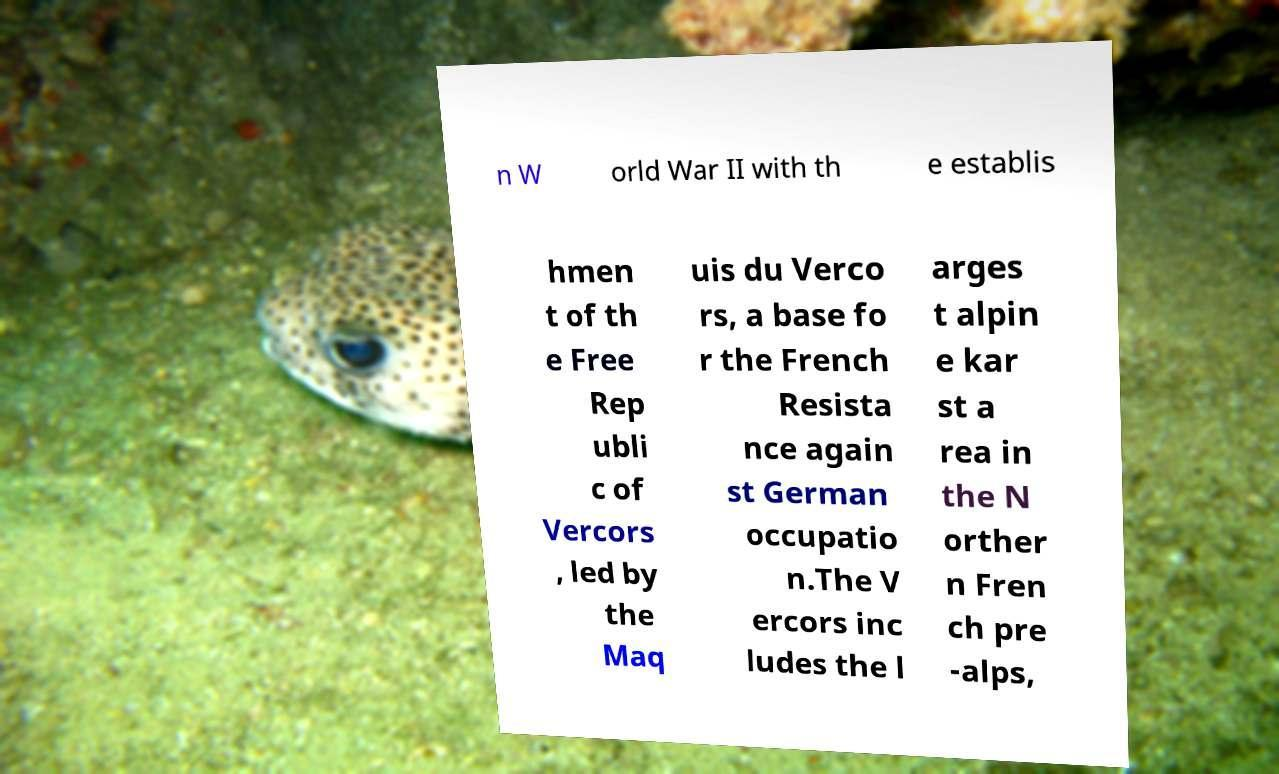For documentation purposes, I need the text within this image transcribed. Could you provide that? n W orld War II with th e establis hmen t of th e Free Rep ubli c of Vercors , led by the Maq uis du Verco rs, a base fo r the French Resista nce again st German occupatio n.The V ercors inc ludes the l arges t alpin e kar st a rea in the N orther n Fren ch pre -alps, 